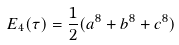Convert formula to latex. <formula><loc_0><loc_0><loc_500><loc_500>E _ { 4 } ( \tau ) = \frac { 1 } { 2 } ( a ^ { 8 } + b ^ { 8 } + c ^ { 8 } )</formula> 